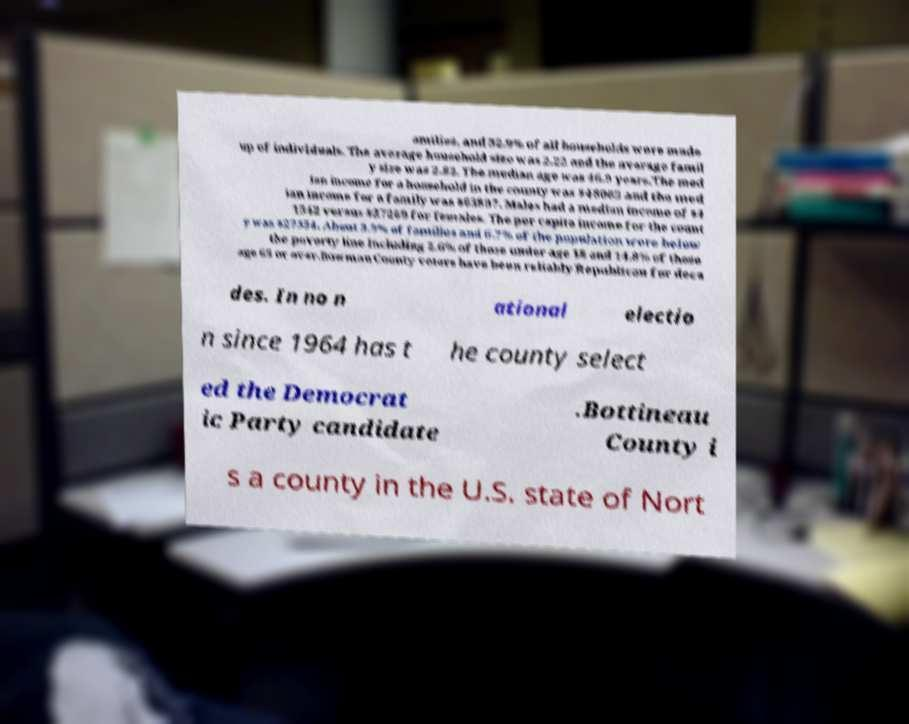Could you extract and type out the text from this image? amilies, and 32.9% of all households were made up of individuals. The average household size was 2.22 and the average famil y size was 2.82. The median age was 46.9 years.The med ian income for a household in the county was $48063 and the med ian income for a family was $63897. Males had a median income of $4 1542 versus $27269 for females. The per capita income for the count y was $27354. About 3.9% of families and 6.7% of the population were below the poverty line including 2.6% of those under age 18 and 14.8% of those age 65 or over.Bowman County voters have been reliably Republican for deca des. In no n ational electio n since 1964 has t he county select ed the Democrat ic Party candidate .Bottineau County i s a county in the U.S. state of Nort 